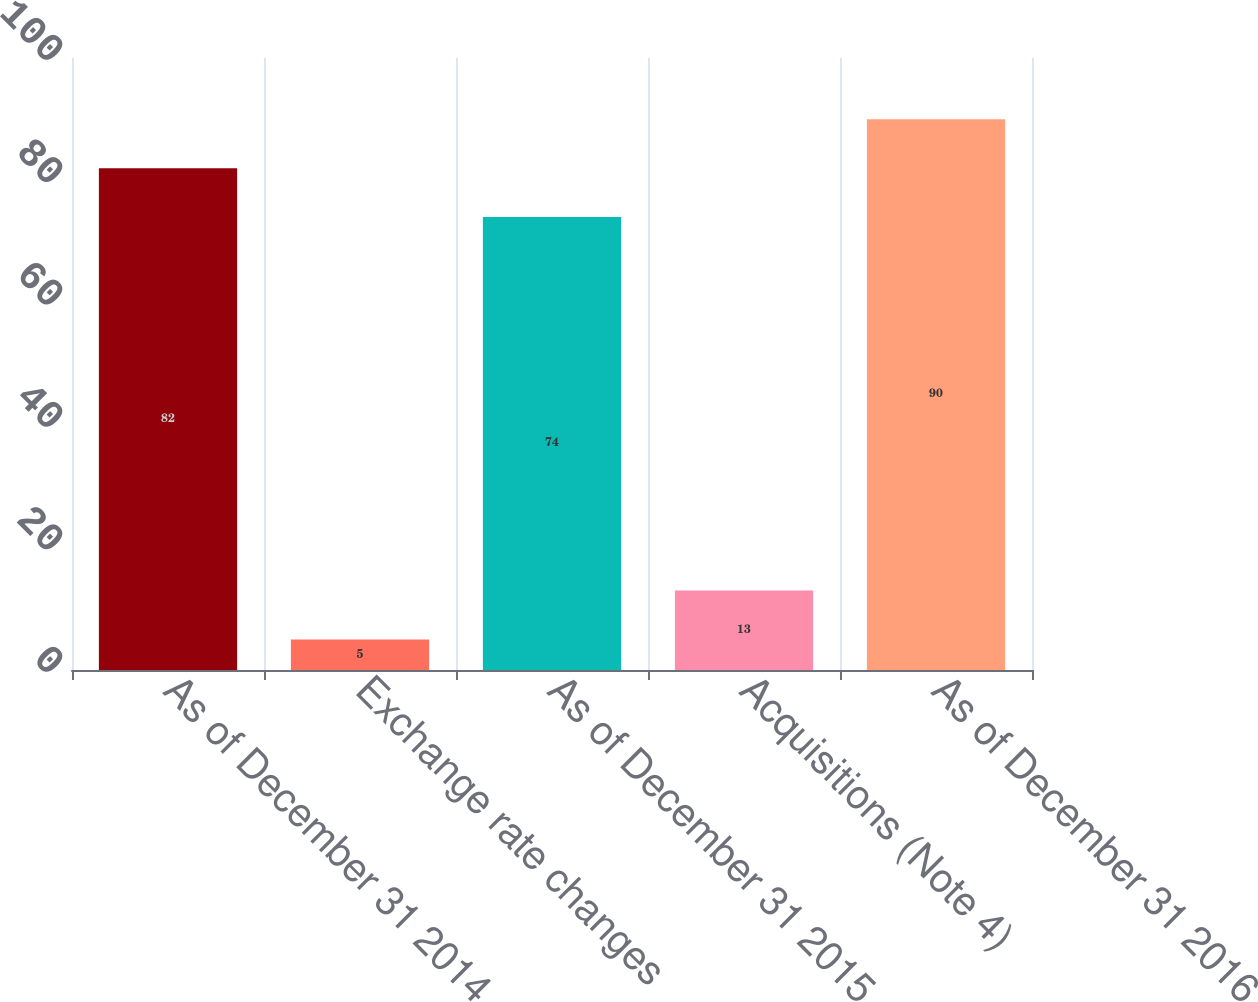Convert chart. <chart><loc_0><loc_0><loc_500><loc_500><bar_chart><fcel>As of December 31 2014<fcel>Exchange rate changes<fcel>As of December 31 2015<fcel>Acquisitions (Note 4)<fcel>As of December 31 2016<nl><fcel>82<fcel>5<fcel>74<fcel>13<fcel>90<nl></chart> 